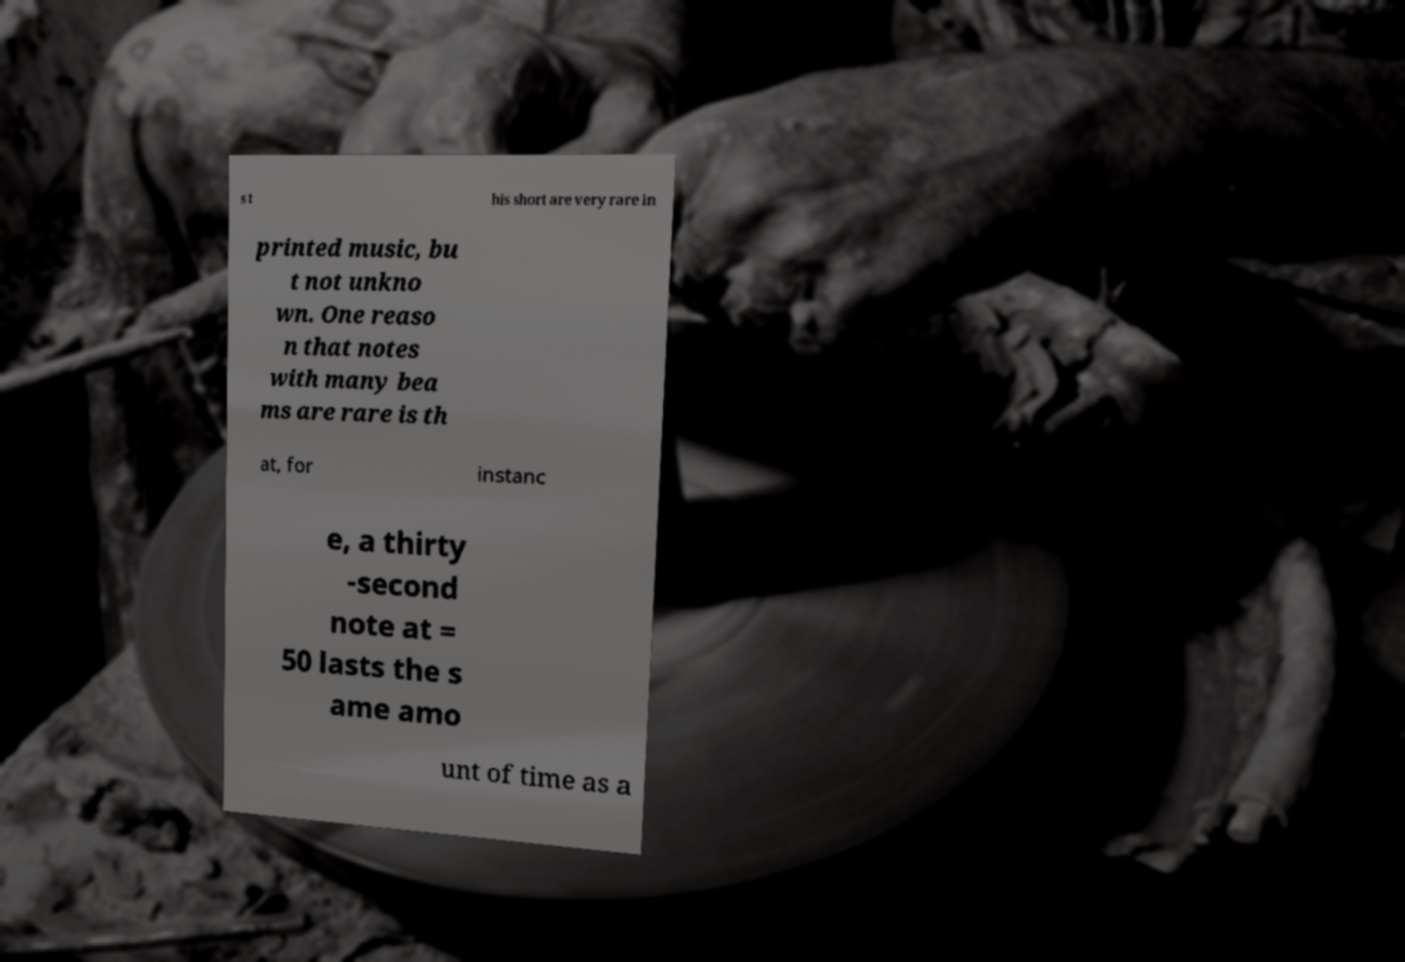There's text embedded in this image that I need extracted. Can you transcribe it verbatim? s t his short are very rare in printed music, bu t not unkno wn. One reaso n that notes with many bea ms are rare is th at, for instanc e, a thirty -second note at = 50 lasts the s ame amo unt of time as a 